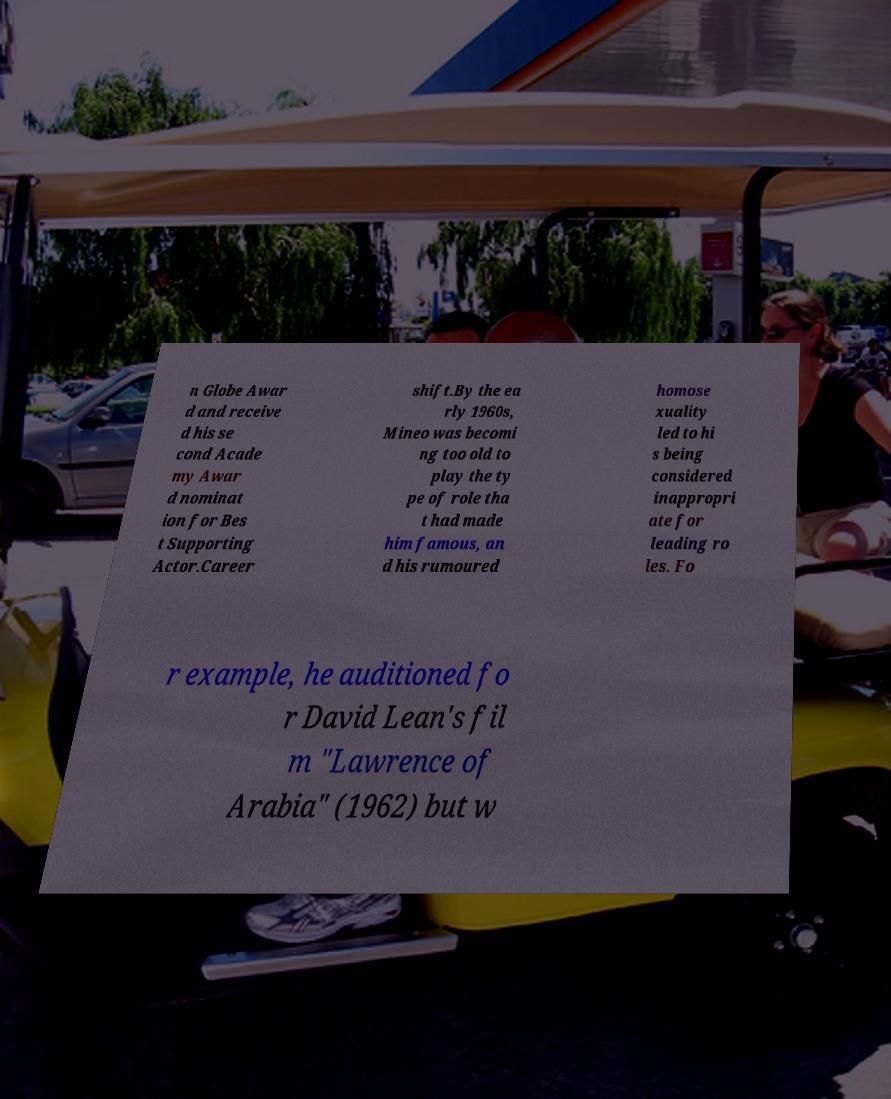For documentation purposes, I need the text within this image transcribed. Could you provide that? n Globe Awar d and receive d his se cond Acade my Awar d nominat ion for Bes t Supporting Actor.Career shift.By the ea rly 1960s, Mineo was becomi ng too old to play the ty pe of role tha t had made him famous, an d his rumoured homose xuality led to hi s being considered inappropri ate for leading ro les. Fo r example, he auditioned fo r David Lean's fil m "Lawrence of Arabia" (1962) but w 